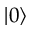<formula> <loc_0><loc_0><loc_500><loc_500>| 0 \rangle</formula> 